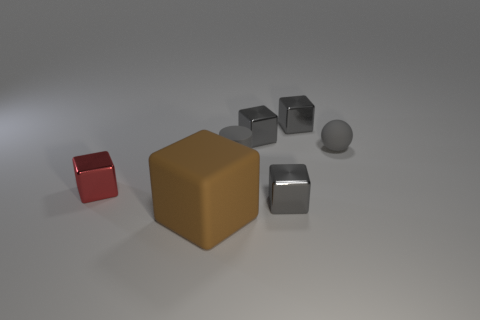There is a small sphere that is the same material as the large cube; what color is it? The small sphere bears the same smooth, metallic texture as the large cube. Considering how the lighting interacts with the material, it appears to be a muted shade of gray, similar to the large cube. 